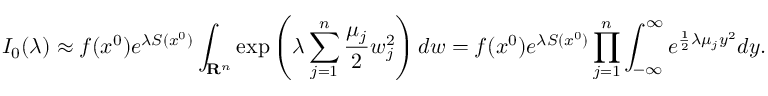<formula> <loc_0><loc_0><loc_500><loc_500>I _ { 0 } ( \lambda ) \approx f ( x ^ { 0 } ) e ^ { \lambda S ( x ^ { 0 } ) } \int _ { R ^ { n } } \exp \left ( \lambda \sum _ { j = 1 } ^ { n } { \frac { \mu _ { j } } { 2 } } w _ { j } ^ { 2 } \right ) d w = f ( x ^ { 0 } ) e ^ { \lambda S ( x ^ { 0 } ) } \prod _ { j = 1 } ^ { n } \int _ { - \infty } ^ { \infty } e ^ { { \frac { 1 } { 2 } } \lambda \mu _ { j } y ^ { 2 } } d y .</formula> 